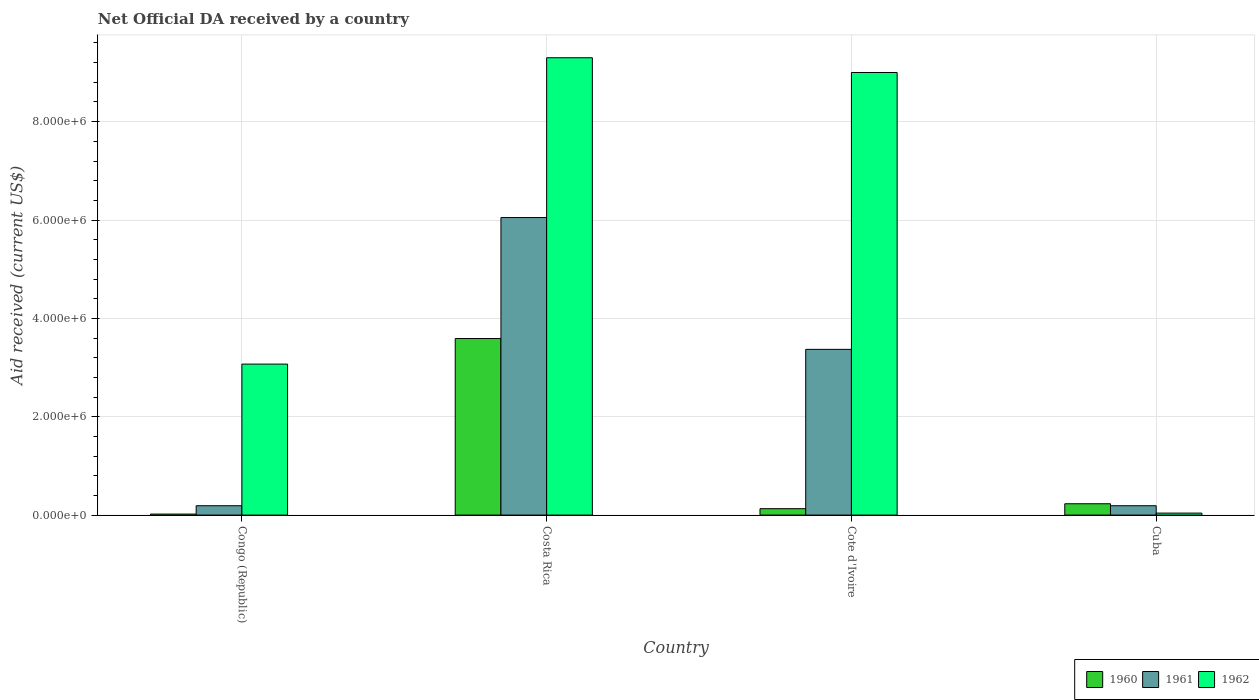Are the number of bars per tick equal to the number of legend labels?
Your answer should be compact. Yes. How many bars are there on the 4th tick from the right?
Make the answer very short. 3. What is the label of the 1st group of bars from the left?
Provide a short and direct response. Congo (Republic). What is the net official development assistance aid received in 1960 in Costa Rica?
Provide a succinct answer. 3.59e+06. Across all countries, what is the maximum net official development assistance aid received in 1961?
Ensure brevity in your answer.  6.05e+06. In which country was the net official development assistance aid received in 1961 minimum?
Give a very brief answer. Congo (Republic). What is the total net official development assistance aid received in 1961 in the graph?
Keep it short and to the point. 9.80e+06. What is the difference between the net official development assistance aid received in 1962 in Congo (Republic) and that in Cote d'Ivoire?
Give a very brief answer. -5.93e+06. What is the difference between the net official development assistance aid received in 1960 in Congo (Republic) and the net official development assistance aid received in 1961 in Cote d'Ivoire?
Your response must be concise. -3.35e+06. What is the average net official development assistance aid received in 1960 per country?
Make the answer very short. 9.92e+05. What is the difference between the net official development assistance aid received of/in 1962 and net official development assistance aid received of/in 1960 in Cote d'Ivoire?
Your answer should be compact. 8.87e+06. In how many countries, is the net official development assistance aid received in 1960 greater than 8400000 US$?
Your response must be concise. 0. What is the ratio of the net official development assistance aid received in 1960 in Congo (Republic) to that in Cote d'Ivoire?
Your answer should be very brief. 0.15. Is the net official development assistance aid received in 1960 in Congo (Republic) less than that in Costa Rica?
Provide a succinct answer. Yes. What is the difference between the highest and the second highest net official development assistance aid received in 1962?
Your answer should be very brief. 6.23e+06. What is the difference between the highest and the lowest net official development assistance aid received in 1962?
Your response must be concise. 9.26e+06. What does the 3rd bar from the right in Cuba represents?
Your answer should be very brief. 1960. Is it the case that in every country, the sum of the net official development assistance aid received in 1962 and net official development assistance aid received in 1961 is greater than the net official development assistance aid received in 1960?
Provide a succinct answer. No. How many countries are there in the graph?
Your answer should be compact. 4. Does the graph contain any zero values?
Offer a terse response. No. Does the graph contain grids?
Provide a succinct answer. Yes. How many legend labels are there?
Give a very brief answer. 3. What is the title of the graph?
Your response must be concise. Net Official DA received by a country. Does "1996" appear as one of the legend labels in the graph?
Provide a succinct answer. No. What is the label or title of the Y-axis?
Keep it short and to the point. Aid received (current US$). What is the Aid received (current US$) in 1960 in Congo (Republic)?
Give a very brief answer. 2.00e+04. What is the Aid received (current US$) of 1961 in Congo (Republic)?
Offer a very short reply. 1.90e+05. What is the Aid received (current US$) in 1962 in Congo (Republic)?
Provide a short and direct response. 3.07e+06. What is the Aid received (current US$) of 1960 in Costa Rica?
Make the answer very short. 3.59e+06. What is the Aid received (current US$) in 1961 in Costa Rica?
Offer a terse response. 6.05e+06. What is the Aid received (current US$) in 1962 in Costa Rica?
Offer a terse response. 9.30e+06. What is the Aid received (current US$) in 1960 in Cote d'Ivoire?
Ensure brevity in your answer.  1.30e+05. What is the Aid received (current US$) in 1961 in Cote d'Ivoire?
Your answer should be very brief. 3.37e+06. What is the Aid received (current US$) of 1962 in Cote d'Ivoire?
Your response must be concise. 9.00e+06. What is the Aid received (current US$) in 1961 in Cuba?
Give a very brief answer. 1.90e+05. What is the Aid received (current US$) of 1962 in Cuba?
Make the answer very short. 4.00e+04. Across all countries, what is the maximum Aid received (current US$) of 1960?
Your response must be concise. 3.59e+06. Across all countries, what is the maximum Aid received (current US$) of 1961?
Provide a succinct answer. 6.05e+06. Across all countries, what is the maximum Aid received (current US$) of 1962?
Your response must be concise. 9.30e+06. Across all countries, what is the minimum Aid received (current US$) of 1960?
Give a very brief answer. 2.00e+04. Across all countries, what is the minimum Aid received (current US$) of 1961?
Ensure brevity in your answer.  1.90e+05. Across all countries, what is the minimum Aid received (current US$) of 1962?
Make the answer very short. 4.00e+04. What is the total Aid received (current US$) in 1960 in the graph?
Provide a short and direct response. 3.97e+06. What is the total Aid received (current US$) of 1961 in the graph?
Your response must be concise. 9.80e+06. What is the total Aid received (current US$) in 1962 in the graph?
Offer a terse response. 2.14e+07. What is the difference between the Aid received (current US$) in 1960 in Congo (Republic) and that in Costa Rica?
Ensure brevity in your answer.  -3.57e+06. What is the difference between the Aid received (current US$) of 1961 in Congo (Republic) and that in Costa Rica?
Offer a very short reply. -5.86e+06. What is the difference between the Aid received (current US$) of 1962 in Congo (Republic) and that in Costa Rica?
Offer a terse response. -6.23e+06. What is the difference between the Aid received (current US$) in 1961 in Congo (Republic) and that in Cote d'Ivoire?
Keep it short and to the point. -3.18e+06. What is the difference between the Aid received (current US$) of 1962 in Congo (Republic) and that in Cote d'Ivoire?
Provide a succinct answer. -5.93e+06. What is the difference between the Aid received (current US$) in 1960 in Congo (Republic) and that in Cuba?
Your answer should be compact. -2.10e+05. What is the difference between the Aid received (current US$) in 1961 in Congo (Republic) and that in Cuba?
Make the answer very short. 0. What is the difference between the Aid received (current US$) of 1962 in Congo (Republic) and that in Cuba?
Ensure brevity in your answer.  3.03e+06. What is the difference between the Aid received (current US$) of 1960 in Costa Rica and that in Cote d'Ivoire?
Ensure brevity in your answer.  3.46e+06. What is the difference between the Aid received (current US$) of 1961 in Costa Rica and that in Cote d'Ivoire?
Your answer should be compact. 2.68e+06. What is the difference between the Aid received (current US$) in 1960 in Costa Rica and that in Cuba?
Keep it short and to the point. 3.36e+06. What is the difference between the Aid received (current US$) in 1961 in Costa Rica and that in Cuba?
Your answer should be compact. 5.86e+06. What is the difference between the Aid received (current US$) in 1962 in Costa Rica and that in Cuba?
Provide a short and direct response. 9.26e+06. What is the difference between the Aid received (current US$) in 1961 in Cote d'Ivoire and that in Cuba?
Provide a short and direct response. 3.18e+06. What is the difference between the Aid received (current US$) of 1962 in Cote d'Ivoire and that in Cuba?
Offer a terse response. 8.96e+06. What is the difference between the Aid received (current US$) in 1960 in Congo (Republic) and the Aid received (current US$) in 1961 in Costa Rica?
Your answer should be compact. -6.03e+06. What is the difference between the Aid received (current US$) in 1960 in Congo (Republic) and the Aid received (current US$) in 1962 in Costa Rica?
Keep it short and to the point. -9.28e+06. What is the difference between the Aid received (current US$) of 1961 in Congo (Republic) and the Aid received (current US$) of 1962 in Costa Rica?
Make the answer very short. -9.11e+06. What is the difference between the Aid received (current US$) in 1960 in Congo (Republic) and the Aid received (current US$) in 1961 in Cote d'Ivoire?
Your answer should be very brief. -3.35e+06. What is the difference between the Aid received (current US$) in 1960 in Congo (Republic) and the Aid received (current US$) in 1962 in Cote d'Ivoire?
Your answer should be very brief. -8.98e+06. What is the difference between the Aid received (current US$) of 1961 in Congo (Republic) and the Aid received (current US$) of 1962 in Cote d'Ivoire?
Your response must be concise. -8.81e+06. What is the difference between the Aid received (current US$) of 1960 in Congo (Republic) and the Aid received (current US$) of 1961 in Cuba?
Your answer should be very brief. -1.70e+05. What is the difference between the Aid received (current US$) of 1961 in Congo (Republic) and the Aid received (current US$) of 1962 in Cuba?
Offer a terse response. 1.50e+05. What is the difference between the Aid received (current US$) of 1960 in Costa Rica and the Aid received (current US$) of 1961 in Cote d'Ivoire?
Your response must be concise. 2.20e+05. What is the difference between the Aid received (current US$) in 1960 in Costa Rica and the Aid received (current US$) in 1962 in Cote d'Ivoire?
Offer a terse response. -5.41e+06. What is the difference between the Aid received (current US$) of 1961 in Costa Rica and the Aid received (current US$) of 1962 in Cote d'Ivoire?
Your answer should be compact. -2.95e+06. What is the difference between the Aid received (current US$) in 1960 in Costa Rica and the Aid received (current US$) in 1961 in Cuba?
Your answer should be very brief. 3.40e+06. What is the difference between the Aid received (current US$) in 1960 in Costa Rica and the Aid received (current US$) in 1962 in Cuba?
Your answer should be compact. 3.55e+06. What is the difference between the Aid received (current US$) in 1961 in Costa Rica and the Aid received (current US$) in 1962 in Cuba?
Offer a very short reply. 6.01e+06. What is the difference between the Aid received (current US$) of 1961 in Cote d'Ivoire and the Aid received (current US$) of 1962 in Cuba?
Offer a terse response. 3.33e+06. What is the average Aid received (current US$) in 1960 per country?
Your response must be concise. 9.92e+05. What is the average Aid received (current US$) in 1961 per country?
Make the answer very short. 2.45e+06. What is the average Aid received (current US$) of 1962 per country?
Keep it short and to the point. 5.35e+06. What is the difference between the Aid received (current US$) in 1960 and Aid received (current US$) in 1961 in Congo (Republic)?
Your response must be concise. -1.70e+05. What is the difference between the Aid received (current US$) in 1960 and Aid received (current US$) in 1962 in Congo (Republic)?
Your response must be concise. -3.05e+06. What is the difference between the Aid received (current US$) in 1961 and Aid received (current US$) in 1962 in Congo (Republic)?
Your response must be concise. -2.88e+06. What is the difference between the Aid received (current US$) of 1960 and Aid received (current US$) of 1961 in Costa Rica?
Provide a succinct answer. -2.46e+06. What is the difference between the Aid received (current US$) of 1960 and Aid received (current US$) of 1962 in Costa Rica?
Your response must be concise. -5.71e+06. What is the difference between the Aid received (current US$) of 1961 and Aid received (current US$) of 1962 in Costa Rica?
Your answer should be compact. -3.25e+06. What is the difference between the Aid received (current US$) of 1960 and Aid received (current US$) of 1961 in Cote d'Ivoire?
Give a very brief answer. -3.24e+06. What is the difference between the Aid received (current US$) in 1960 and Aid received (current US$) in 1962 in Cote d'Ivoire?
Make the answer very short. -8.87e+06. What is the difference between the Aid received (current US$) of 1961 and Aid received (current US$) of 1962 in Cote d'Ivoire?
Provide a succinct answer. -5.63e+06. What is the ratio of the Aid received (current US$) of 1960 in Congo (Republic) to that in Costa Rica?
Your response must be concise. 0.01. What is the ratio of the Aid received (current US$) in 1961 in Congo (Republic) to that in Costa Rica?
Keep it short and to the point. 0.03. What is the ratio of the Aid received (current US$) of 1962 in Congo (Republic) to that in Costa Rica?
Your answer should be compact. 0.33. What is the ratio of the Aid received (current US$) in 1960 in Congo (Republic) to that in Cote d'Ivoire?
Give a very brief answer. 0.15. What is the ratio of the Aid received (current US$) in 1961 in Congo (Republic) to that in Cote d'Ivoire?
Provide a succinct answer. 0.06. What is the ratio of the Aid received (current US$) of 1962 in Congo (Republic) to that in Cote d'Ivoire?
Your response must be concise. 0.34. What is the ratio of the Aid received (current US$) of 1960 in Congo (Republic) to that in Cuba?
Keep it short and to the point. 0.09. What is the ratio of the Aid received (current US$) in 1961 in Congo (Republic) to that in Cuba?
Your answer should be very brief. 1. What is the ratio of the Aid received (current US$) in 1962 in Congo (Republic) to that in Cuba?
Provide a short and direct response. 76.75. What is the ratio of the Aid received (current US$) in 1960 in Costa Rica to that in Cote d'Ivoire?
Make the answer very short. 27.62. What is the ratio of the Aid received (current US$) in 1961 in Costa Rica to that in Cote d'Ivoire?
Your answer should be compact. 1.8. What is the ratio of the Aid received (current US$) of 1960 in Costa Rica to that in Cuba?
Provide a short and direct response. 15.61. What is the ratio of the Aid received (current US$) of 1961 in Costa Rica to that in Cuba?
Your answer should be compact. 31.84. What is the ratio of the Aid received (current US$) in 1962 in Costa Rica to that in Cuba?
Your answer should be compact. 232.5. What is the ratio of the Aid received (current US$) in 1960 in Cote d'Ivoire to that in Cuba?
Provide a short and direct response. 0.57. What is the ratio of the Aid received (current US$) of 1961 in Cote d'Ivoire to that in Cuba?
Provide a succinct answer. 17.74. What is the ratio of the Aid received (current US$) in 1962 in Cote d'Ivoire to that in Cuba?
Offer a terse response. 225. What is the difference between the highest and the second highest Aid received (current US$) of 1960?
Provide a succinct answer. 3.36e+06. What is the difference between the highest and the second highest Aid received (current US$) of 1961?
Your answer should be very brief. 2.68e+06. What is the difference between the highest and the second highest Aid received (current US$) in 1962?
Your answer should be very brief. 3.00e+05. What is the difference between the highest and the lowest Aid received (current US$) of 1960?
Give a very brief answer. 3.57e+06. What is the difference between the highest and the lowest Aid received (current US$) of 1961?
Your answer should be compact. 5.86e+06. What is the difference between the highest and the lowest Aid received (current US$) in 1962?
Provide a succinct answer. 9.26e+06. 